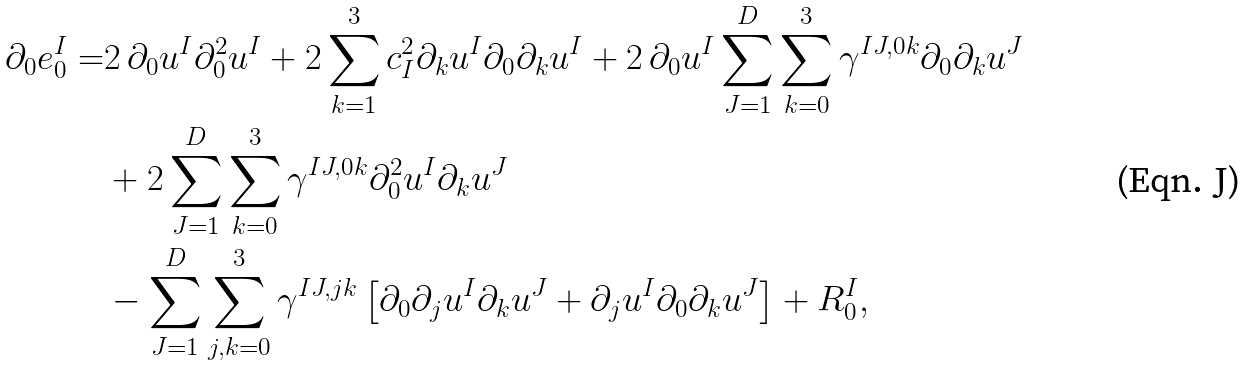<formula> <loc_0><loc_0><loc_500><loc_500>\partial _ { 0 } e _ { 0 } ^ { I } = & 2 \, \partial _ { 0 } u ^ { I } \partial _ { 0 } ^ { 2 } u ^ { I } + 2 \sum _ { k = 1 } ^ { 3 } c ^ { 2 } _ { I } \partial _ { k } u ^ { I } \partial _ { 0 } \partial _ { k } u ^ { I } + 2 \, \partial _ { 0 } u ^ { I } \sum _ { J = 1 } ^ { D } \sum _ { k = 0 } ^ { 3 } \gamma ^ { I J , 0 k } \partial _ { 0 } \partial _ { k } u ^ { J } \\ & + 2 \sum _ { J = 1 } ^ { D } \sum _ { k = 0 } ^ { 3 } \gamma ^ { I J , 0 k } \partial ^ { 2 } _ { 0 } u ^ { I } \partial _ { k } u ^ { J } \\ & - \sum _ { J = 1 } ^ { D } \sum _ { j , k = 0 } ^ { 3 } \gamma ^ { I J , j k } \left [ \partial _ { 0 } \partial _ { j } u ^ { I } \partial _ { k } u ^ { J } + \partial _ { j } u ^ { I } \partial _ { 0 } \partial _ { k } u ^ { J } \right ] + R _ { 0 } ^ { I } ,</formula> 